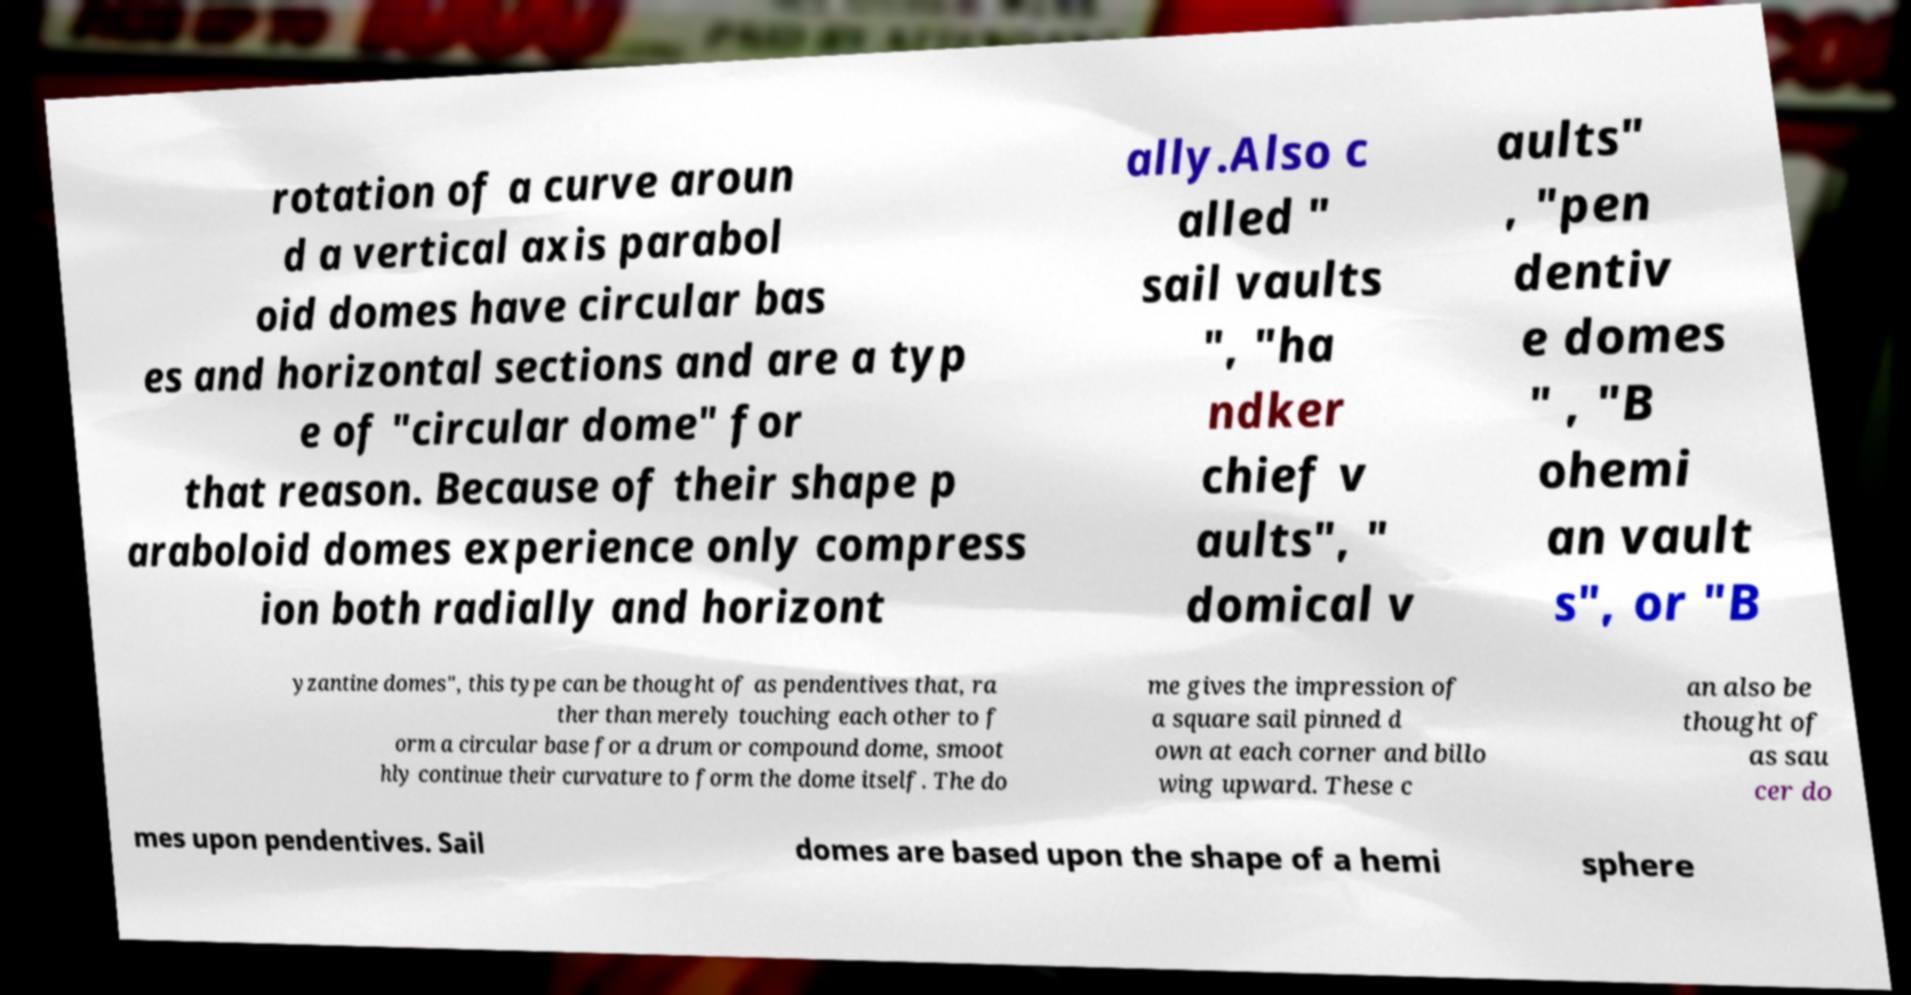For documentation purposes, I need the text within this image transcribed. Could you provide that? rotation of a curve aroun d a vertical axis parabol oid domes have circular bas es and horizontal sections and are a typ e of "circular dome" for that reason. Because of their shape p araboloid domes experience only compress ion both radially and horizont ally.Also c alled " sail vaults ", "ha ndker chief v aults", " domical v aults" , "pen dentiv e domes " , "B ohemi an vault s", or "B yzantine domes", this type can be thought of as pendentives that, ra ther than merely touching each other to f orm a circular base for a drum or compound dome, smoot hly continue their curvature to form the dome itself. The do me gives the impression of a square sail pinned d own at each corner and billo wing upward. These c an also be thought of as sau cer do mes upon pendentives. Sail domes are based upon the shape of a hemi sphere 